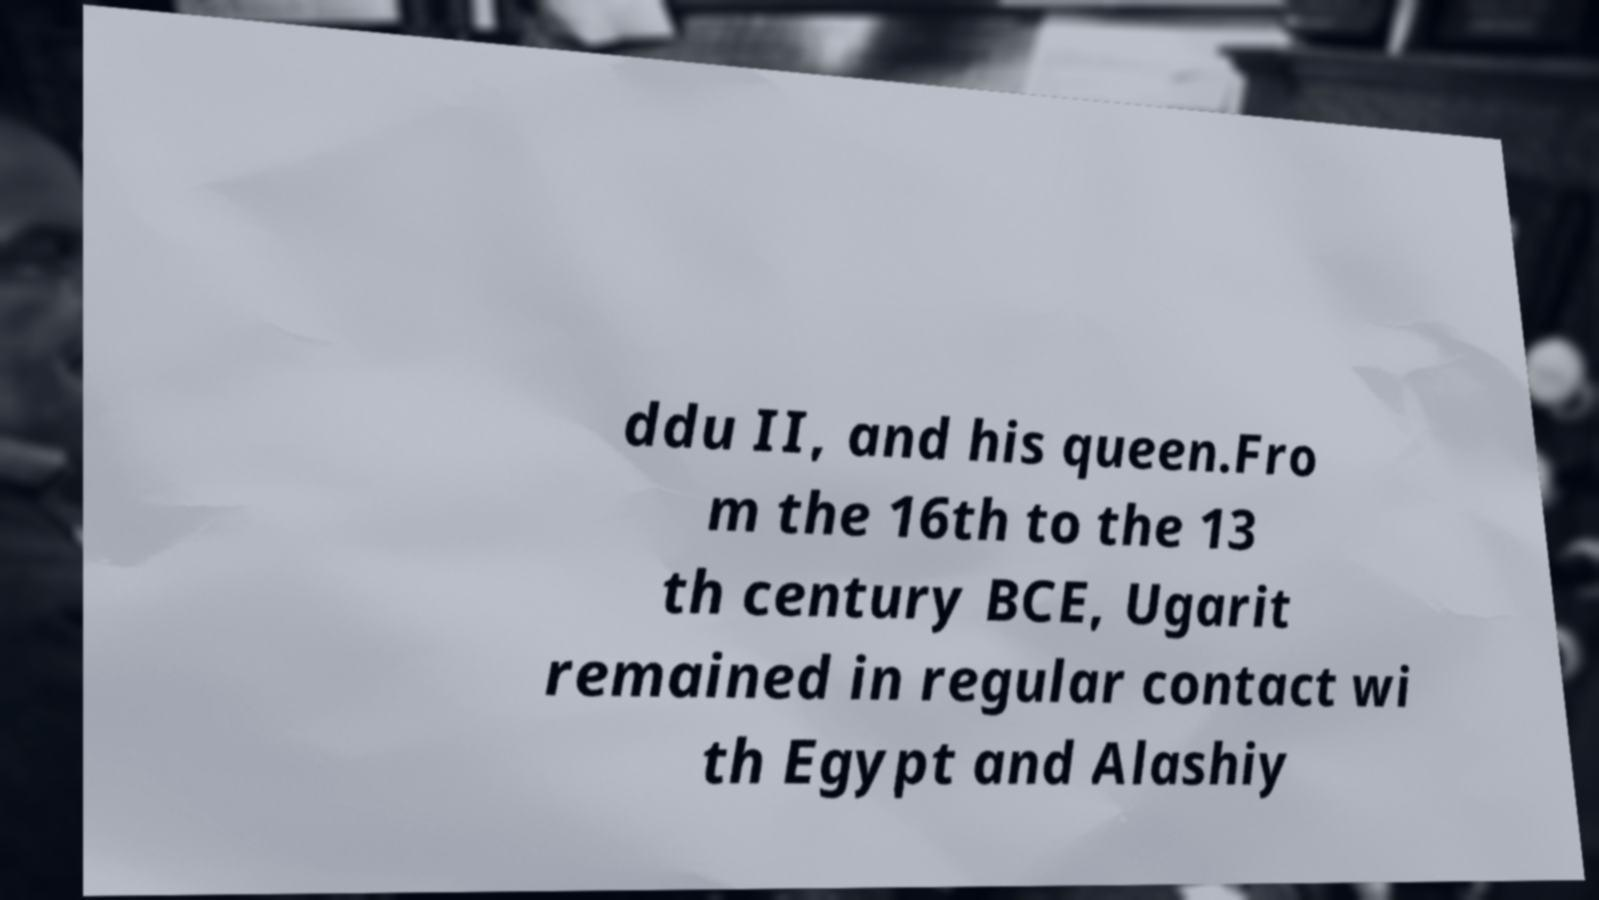Can you read and provide the text displayed in the image?This photo seems to have some interesting text. Can you extract and type it out for me? ddu II, and his queen.Fro m the 16th to the 13 th century BCE, Ugarit remained in regular contact wi th Egypt and Alashiy 